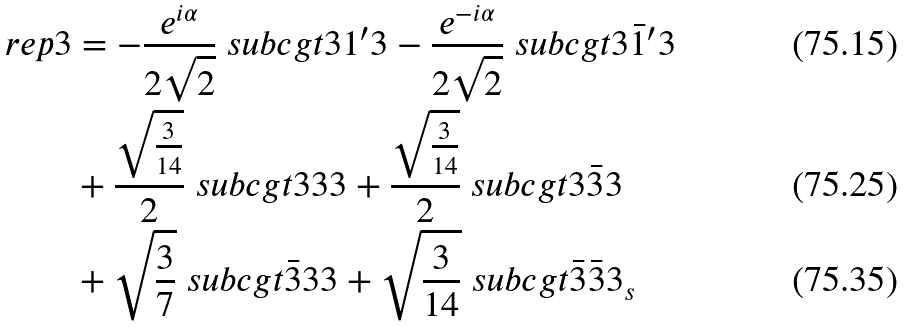<formula> <loc_0><loc_0><loc_500><loc_500>\ r e p { 3 } & = - \frac { e ^ { i \alpha } } { 2 \sqrt { 2 } } \ s u b c g t { 3 } { 1 ^ { \prime } } { 3 } - \frac { e ^ { - i \alpha } } { 2 \sqrt { 2 } } \ s u b c g t { 3 } { \bar { 1 } ^ { \prime } } { 3 } \\ & + \frac { \sqrt { \frac { 3 } { 1 4 } } } { 2 } \ s u b c g t { 3 } { 3 } { 3 } + \frac { \sqrt { \frac { 3 } { 1 4 } } } { 2 } \ s u b c g t { 3 } { \bar { 3 } } { 3 } \\ & + \sqrt { \frac { 3 } { 7 } } \ s u b c g t { \bar { 3 } } { 3 } { 3 } + \sqrt { \frac { 3 } { 1 4 } } \ s u b c g t { \bar { 3 } } { \bar { 3 } } { 3 _ { s } }</formula> 